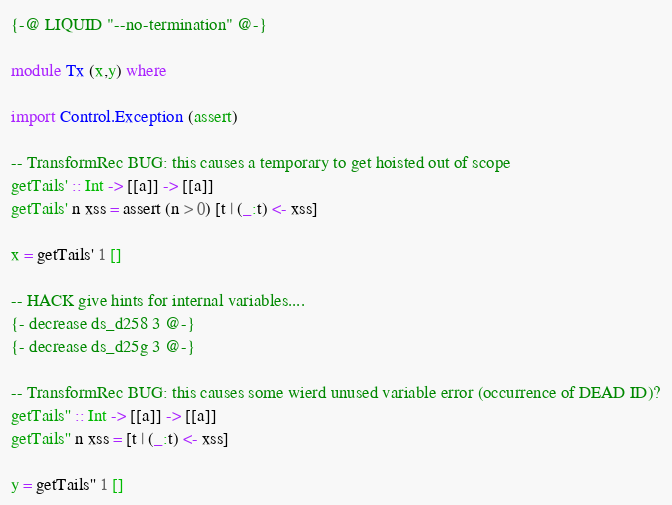Convert code to text. <code><loc_0><loc_0><loc_500><loc_500><_Haskell_>{-@ LIQUID "--no-termination" @-}

module Tx (x,y) where

import Control.Exception (assert)

-- TransformRec BUG: this causes a temporary to get hoisted out of scope
getTails' :: Int -> [[a]] -> [[a]]
getTails' n xss = assert (n > 0) [t | (_:t) <- xss]

x = getTails' 1 []

-- HACK give hints for internal variables....
{- decrease ds_d258 3 @-}
{- decrease ds_d25g 3 @-}

-- TransformRec BUG: this causes some wierd unused variable error (occurrence of DEAD ID)?
getTails'' :: Int -> [[a]] -> [[a]]
getTails'' n xss = [t | (_:t) <- xss]

y = getTails'' 1 []
</code> 